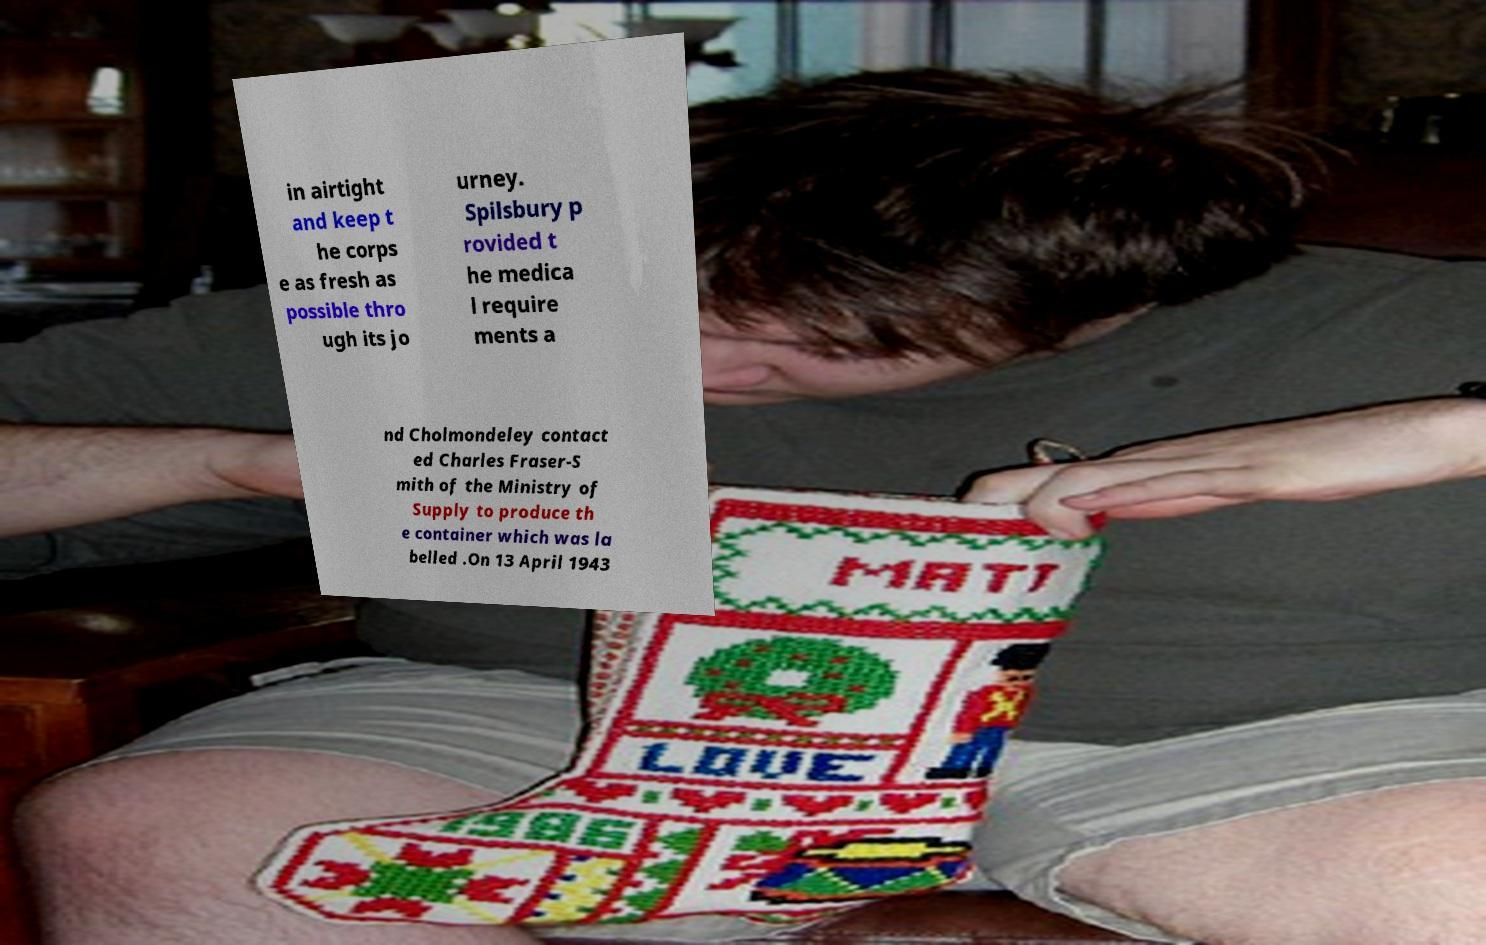Can you read and provide the text displayed in the image?This photo seems to have some interesting text. Can you extract and type it out for me? in airtight and keep t he corps e as fresh as possible thro ugh its jo urney. Spilsbury p rovided t he medica l require ments a nd Cholmondeley contact ed Charles Fraser-S mith of the Ministry of Supply to produce th e container which was la belled .On 13 April 1943 